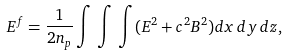Convert formula to latex. <formula><loc_0><loc_0><loc_500><loc_500>E ^ { f } = \frac { 1 } { 2 n _ { p } } \int \, \int \, \int ( E ^ { 2 } + c ^ { 2 } B ^ { 2 } ) d x \, d y \, d z ,</formula> 